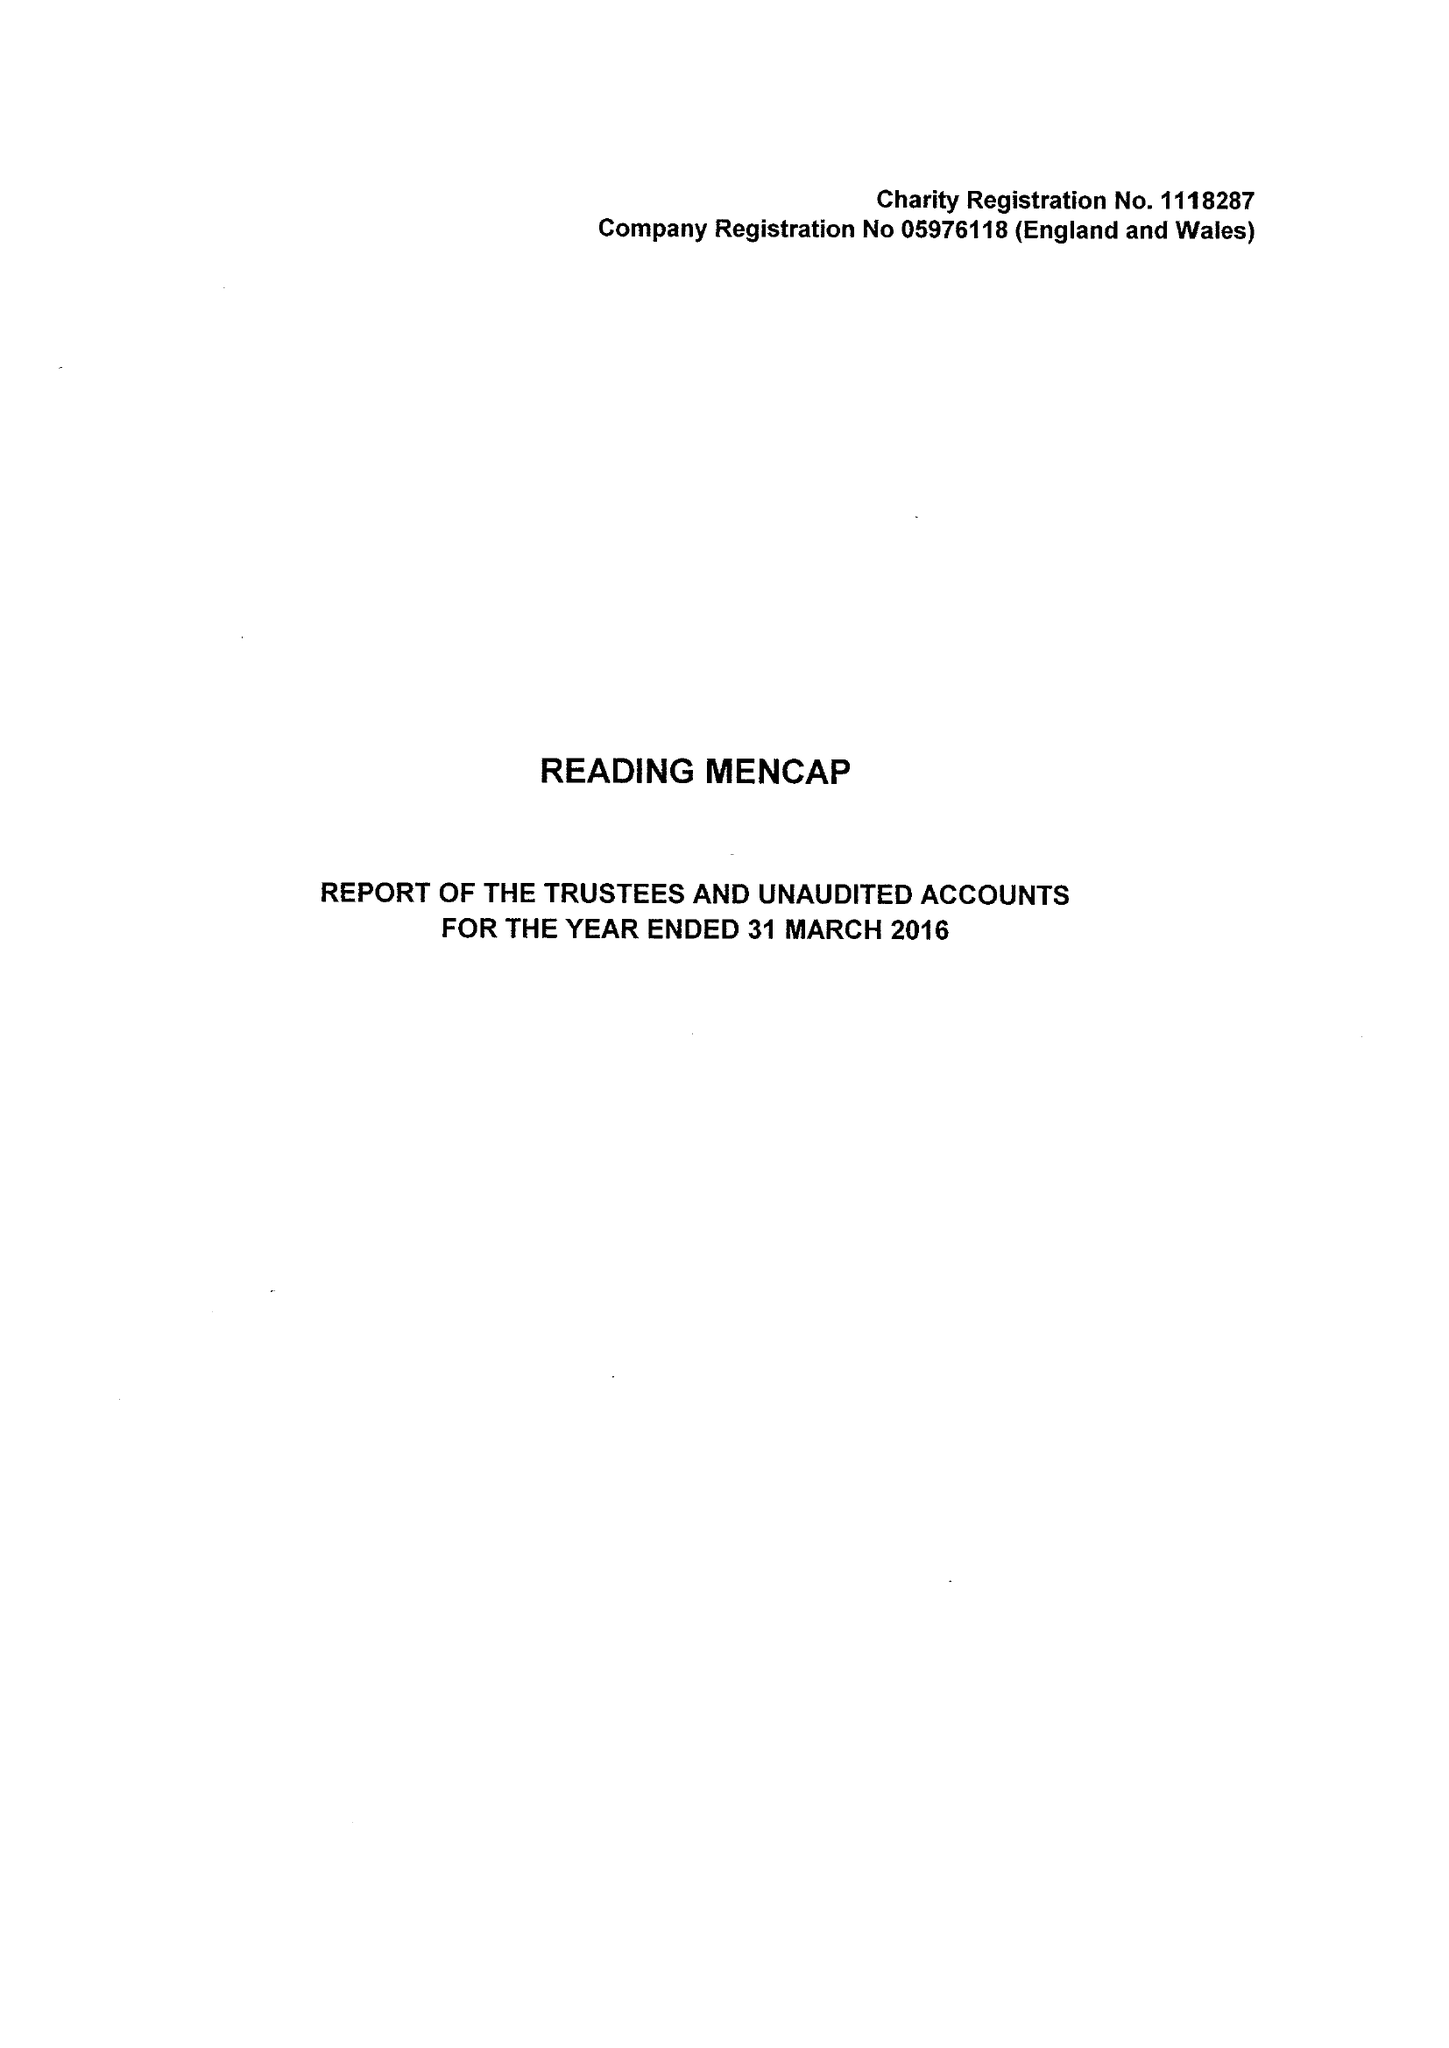What is the value for the address__post_town?
Answer the question using a single word or phrase. READING 